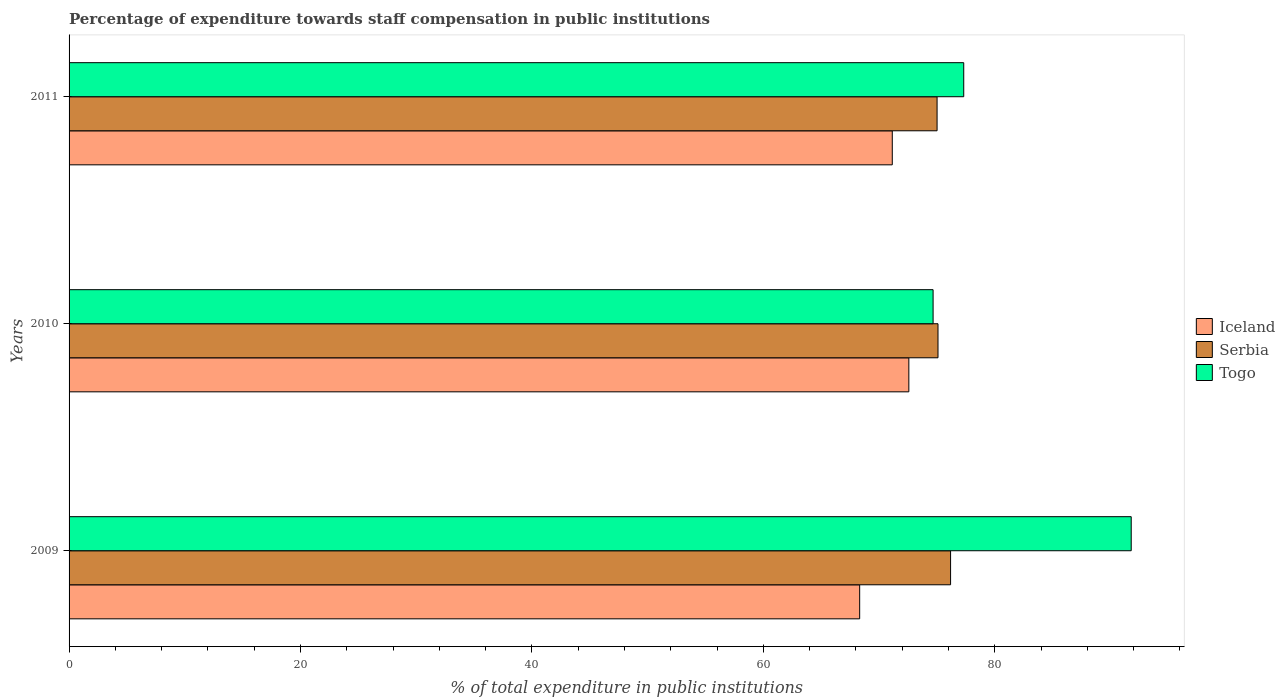Are the number of bars per tick equal to the number of legend labels?
Keep it short and to the point. Yes. Are the number of bars on each tick of the Y-axis equal?
Your response must be concise. Yes. How many bars are there on the 1st tick from the top?
Your answer should be very brief. 3. How many bars are there on the 2nd tick from the bottom?
Provide a succinct answer. 3. In how many cases, is the number of bars for a given year not equal to the number of legend labels?
Provide a short and direct response. 0. What is the percentage of expenditure towards staff compensation in Serbia in 2010?
Offer a very short reply. 75.09. Across all years, what is the maximum percentage of expenditure towards staff compensation in Serbia?
Make the answer very short. 76.18. Across all years, what is the minimum percentage of expenditure towards staff compensation in Iceland?
Offer a terse response. 68.32. In which year was the percentage of expenditure towards staff compensation in Togo minimum?
Provide a succinct answer. 2010. What is the total percentage of expenditure towards staff compensation in Iceland in the graph?
Your answer should be very brief. 212.03. What is the difference between the percentage of expenditure towards staff compensation in Iceland in 2009 and that in 2010?
Ensure brevity in your answer.  -4.25. What is the difference between the percentage of expenditure towards staff compensation in Serbia in 2010 and the percentage of expenditure towards staff compensation in Iceland in 2009?
Give a very brief answer. 6.77. What is the average percentage of expenditure towards staff compensation in Iceland per year?
Offer a very short reply. 70.68. In the year 2010, what is the difference between the percentage of expenditure towards staff compensation in Serbia and percentage of expenditure towards staff compensation in Togo?
Provide a short and direct response. 0.42. In how many years, is the percentage of expenditure towards staff compensation in Serbia greater than 20 %?
Ensure brevity in your answer.  3. What is the ratio of the percentage of expenditure towards staff compensation in Togo in 2010 to that in 2011?
Provide a succinct answer. 0.97. Is the percentage of expenditure towards staff compensation in Iceland in 2009 less than that in 2011?
Provide a short and direct response. Yes. Is the difference between the percentage of expenditure towards staff compensation in Serbia in 2009 and 2011 greater than the difference between the percentage of expenditure towards staff compensation in Togo in 2009 and 2011?
Offer a very short reply. No. What is the difference between the highest and the second highest percentage of expenditure towards staff compensation in Serbia?
Offer a very short reply. 1.09. What is the difference between the highest and the lowest percentage of expenditure towards staff compensation in Iceland?
Give a very brief answer. 4.25. What does the 1st bar from the top in 2009 represents?
Make the answer very short. Togo. What does the 3rd bar from the bottom in 2011 represents?
Your answer should be compact. Togo. Is it the case that in every year, the sum of the percentage of expenditure towards staff compensation in Serbia and percentage of expenditure towards staff compensation in Iceland is greater than the percentage of expenditure towards staff compensation in Togo?
Offer a very short reply. Yes. Are all the bars in the graph horizontal?
Give a very brief answer. Yes. What is the difference between two consecutive major ticks on the X-axis?
Keep it short and to the point. 20. Are the values on the major ticks of X-axis written in scientific E-notation?
Your answer should be very brief. No. Does the graph contain grids?
Offer a very short reply. No. How many legend labels are there?
Provide a short and direct response. 3. What is the title of the graph?
Keep it short and to the point. Percentage of expenditure towards staff compensation in public institutions. Does "Mozambique" appear as one of the legend labels in the graph?
Make the answer very short. No. What is the label or title of the X-axis?
Provide a succinct answer. % of total expenditure in public institutions. What is the label or title of the Y-axis?
Offer a very short reply. Years. What is the % of total expenditure in public institutions of Iceland in 2009?
Offer a terse response. 68.32. What is the % of total expenditure in public institutions of Serbia in 2009?
Ensure brevity in your answer.  76.18. What is the % of total expenditure in public institutions of Togo in 2009?
Ensure brevity in your answer.  91.79. What is the % of total expenditure in public institutions in Iceland in 2010?
Ensure brevity in your answer.  72.57. What is the % of total expenditure in public institutions of Serbia in 2010?
Offer a very short reply. 75.09. What is the % of total expenditure in public institutions of Togo in 2010?
Provide a succinct answer. 74.67. What is the % of total expenditure in public institutions in Iceland in 2011?
Your answer should be compact. 71.14. What is the % of total expenditure in public institutions of Serbia in 2011?
Ensure brevity in your answer.  75.01. What is the % of total expenditure in public institutions of Togo in 2011?
Offer a terse response. 77.31. Across all years, what is the maximum % of total expenditure in public institutions in Iceland?
Give a very brief answer. 72.57. Across all years, what is the maximum % of total expenditure in public institutions in Serbia?
Ensure brevity in your answer.  76.18. Across all years, what is the maximum % of total expenditure in public institutions in Togo?
Give a very brief answer. 91.79. Across all years, what is the minimum % of total expenditure in public institutions of Iceland?
Give a very brief answer. 68.32. Across all years, what is the minimum % of total expenditure in public institutions of Serbia?
Offer a terse response. 75.01. Across all years, what is the minimum % of total expenditure in public institutions of Togo?
Offer a very short reply. 74.67. What is the total % of total expenditure in public institutions in Iceland in the graph?
Keep it short and to the point. 212.03. What is the total % of total expenditure in public institutions in Serbia in the graph?
Your response must be concise. 226.27. What is the total % of total expenditure in public institutions in Togo in the graph?
Offer a terse response. 243.76. What is the difference between the % of total expenditure in public institutions of Iceland in 2009 and that in 2010?
Provide a short and direct response. -4.25. What is the difference between the % of total expenditure in public institutions of Serbia in 2009 and that in 2010?
Keep it short and to the point. 1.09. What is the difference between the % of total expenditure in public institutions of Togo in 2009 and that in 2010?
Your response must be concise. 17.12. What is the difference between the % of total expenditure in public institutions of Iceland in 2009 and that in 2011?
Give a very brief answer. -2.82. What is the difference between the % of total expenditure in public institutions in Serbia in 2009 and that in 2011?
Your answer should be compact. 1.17. What is the difference between the % of total expenditure in public institutions in Togo in 2009 and that in 2011?
Provide a succinct answer. 14.47. What is the difference between the % of total expenditure in public institutions of Iceland in 2010 and that in 2011?
Your answer should be compact. 1.43. What is the difference between the % of total expenditure in public institutions in Serbia in 2010 and that in 2011?
Your response must be concise. 0.08. What is the difference between the % of total expenditure in public institutions of Togo in 2010 and that in 2011?
Make the answer very short. -2.65. What is the difference between the % of total expenditure in public institutions in Iceland in 2009 and the % of total expenditure in public institutions in Serbia in 2010?
Give a very brief answer. -6.77. What is the difference between the % of total expenditure in public institutions in Iceland in 2009 and the % of total expenditure in public institutions in Togo in 2010?
Offer a very short reply. -6.35. What is the difference between the % of total expenditure in public institutions of Serbia in 2009 and the % of total expenditure in public institutions of Togo in 2010?
Keep it short and to the point. 1.51. What is the difference between the % of total expenditure in public institutions in Iceland in 2009 and the % of total expenditure in public institutions in Serbia in 2011?
Offer a terse response. -6.69. What is the difference between the % of total expenditure in public institutions of Iceland in 2009 and the % of total expenditure in public institutions of Togo in 2011?
Your response must be concise. -8.99. What is the difference between the % of total expenditure in public institutions of Serbia in 2009 and the % of total expenditure in public institutions of Togo in 2011?
Keep it short and to the point. -1.14. What is the difference between the % of total expenditure in public institutions in Iceland in 2010 and the % of total expenditure in public institutions in Serbia in 2011?
Make the answer very short. -2.44. What is the difference between the % of total expenditure in public institutions of Iceland in 2010 and the % of total expenditure in public institutions of Togo in 2011?
Provide a short and direct response. -4.74. What is the difference between the % of total expenditure in public institutions of Serbia in 2010 and the % of total expenditure in public institutions of Togo in 2011?
Offer a very short reply. -2.22. What is the average % of total expenditure in public institutions of Iceland per year?
Offer a very short reply. 70.68. What is the average % of total expenditure in public institutions in Serbia per year?
Offer a terse response. 75.42. What is the average % of total expenditure in public institutions in Togo per year?
Offer a very short reply. 81.25. In the year 2009, what is the difference between the % of total expenditure in public institutions of Iceland and % of total expenditure in public institutions of Serbia?
Offer a terse response. -7.86. In the year 2009, what is the difference between the % of total expenditure in public institutions in Iceland and % of total expenditure in public institutions in Togo?
Give a very brief answer. -23.47. In the year 2009, what is the difference between the % of total expenditure in public institutions in Serbia and % of total expenditure in public institutions in Togo?
Make the answer very short. -15.61. In the year 2010, what is the difference between the % of total expenditure in public institutions in Iceland and % of total expenditure in public institutions in Serbia?
Offer a very short reply. -2.52. In the year 2010, what is the difference between the % of total expenditure in public institutions of Iceland and % of total expenditure in public institutions of Togo?
Your answer should be very brief. -2.1. In the year 2010, what is the difference between the % of total expenditure in public institutions of Serbia and % of total expenditure in public institutions of Togo?
Give a very brief answer. 0.42. In the year 2011, what is the difference between the % of total expenditure in public institutions in Iceland and % of total expenditure in public institutions in Serbia?
Provide a succinct answer. -3.87. In the year 2011, what is the difference between the % of total expenditure in public institutions of Iceland and % of total expenditure in public institutions of Togo?
Offer a terse response. -6.18. In the year 2011, what is the difference between the % of total expenditure in public institutions of Serbia and % of total expenditure in public institutions of Togo?
Offer a very short reply. -2.3. What is the ratio of the % of total expenditure in public institutions of Iceland in 2009 to that in 2010?
Offer a very short reply. 0.94. What is the ratio of the % of total expenditure in public institutions of Serbia in 2009 to that in 2010?
Ensure brevity in your answer.  1.01. What is the ratio of the % of total expenditure in public institutions in Togo in 2009 to that in 2010?
Your answer should be very brief. 1.23. What is the ratio of the % of total expenditure in public institutions of Iceland in 2009 to that in 2011?
Provide a short and direct response. 0.96. What is the ratio of the % of total expenditure in public institutions of Serbia in 2009 to that in 2011?
Offer a very short reply. 1.02. What is the ratio of the % of total expenditure in public institutions of Togo in 2009 to that in 2011?
Your response must be concise. 1.19. What is the ratio of the % of total expenditure in public institutions in Iceland in 2010 to that in 2011?
Keep it short and to the point. 1.02. What is the ratio of the % of total expenditure in public institutions in Serbia in 2010 to that in 2011?
Your answer should be very brief. 1. What is the ratio of the % of total expenditure in public institutions of Togo in 2010 to that in 2011?
Keep it short and to the point. 0.97. What is the difference between the highest and the second highest % of total expenditure in public institutions of Iceland?
Keep it short and to the point. 1.43. What is the difference between the highest and the second highest % of total expenditure in public institutions in Serbia?
Provide a succinct answer. 1.09. What is the difference between the highest and the second highest % of total expenditure in public institutions in Togo?
Offer a terse response. 14.47. What is the difference between the highest and the lowest % of total expenditure in public institutions of Iceland?
Ensure brevity in your answer.  4.25. What is the difference between the highest and the lowest % of total expenditure in public institutions of Serbia?
Provide a succinct answer. 1.17. What is the difference between the highest and the lowest % of total expenditure in public institutions in Togo?
Offer a terse response. 17.12. 